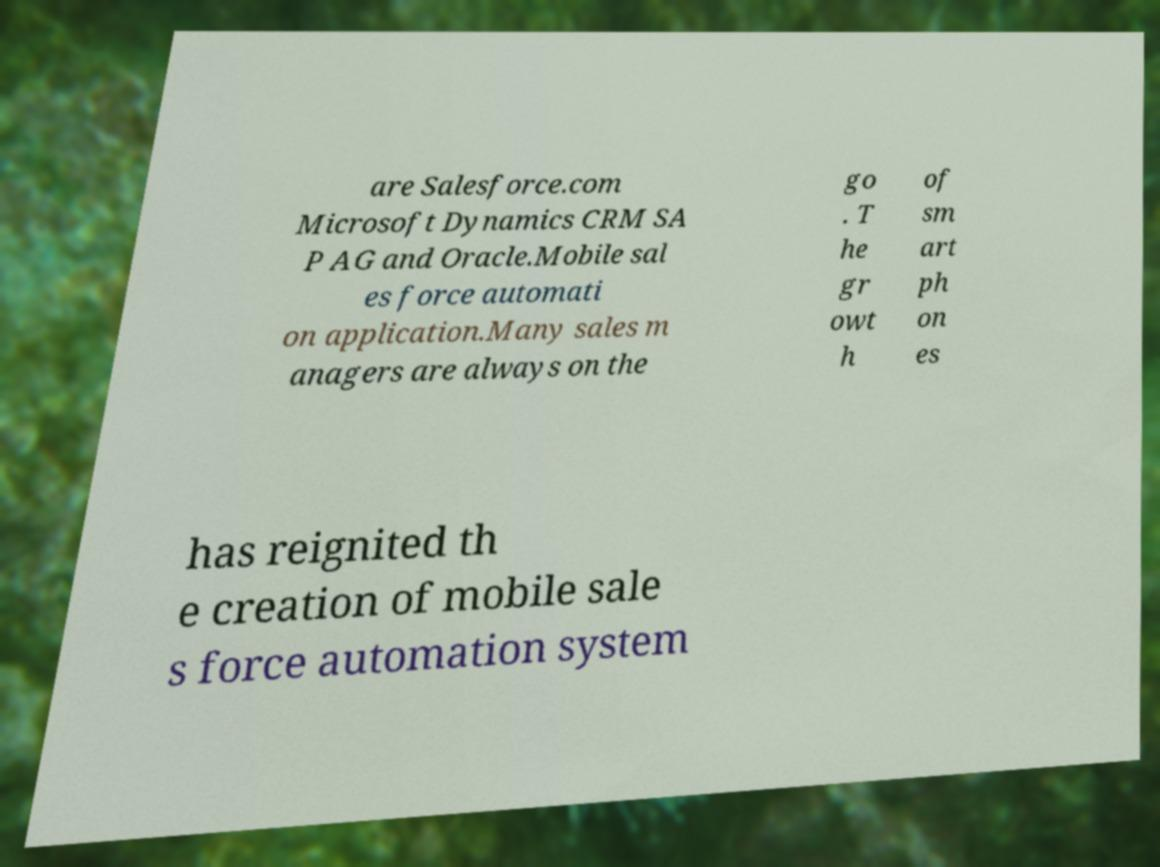Can you accurately transcribe the text from the provided image for me? are Salesforce.com Microsoft Dynamics CRM SA P AG and Oracle.Mobile sal es force automati on application.Many sales m anagers are always on the go . T he gr owt h of sm art ph on es has reignited th e creation of mobile sale s force automation system 